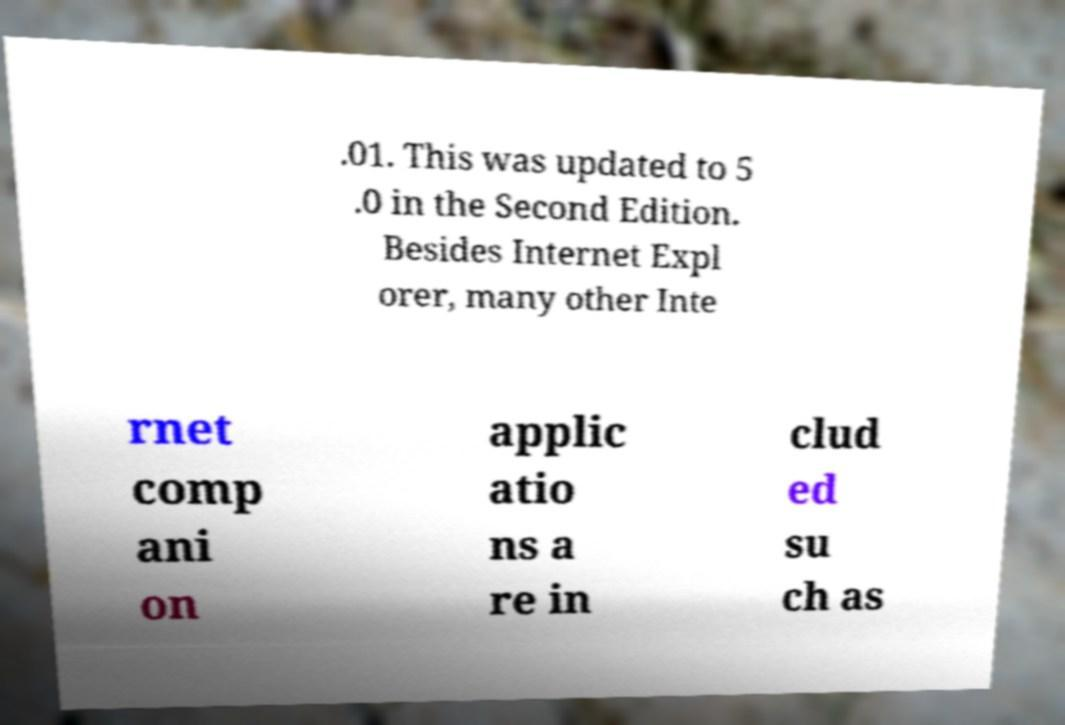Can you accurately transcribe the text from the provided image for me? .01. This was updated to 5 .0 in the Second Edition. Besides Internet Expl orer, many other Inte rnet comp ani on applic atio ns a re in clud ed su ch as 